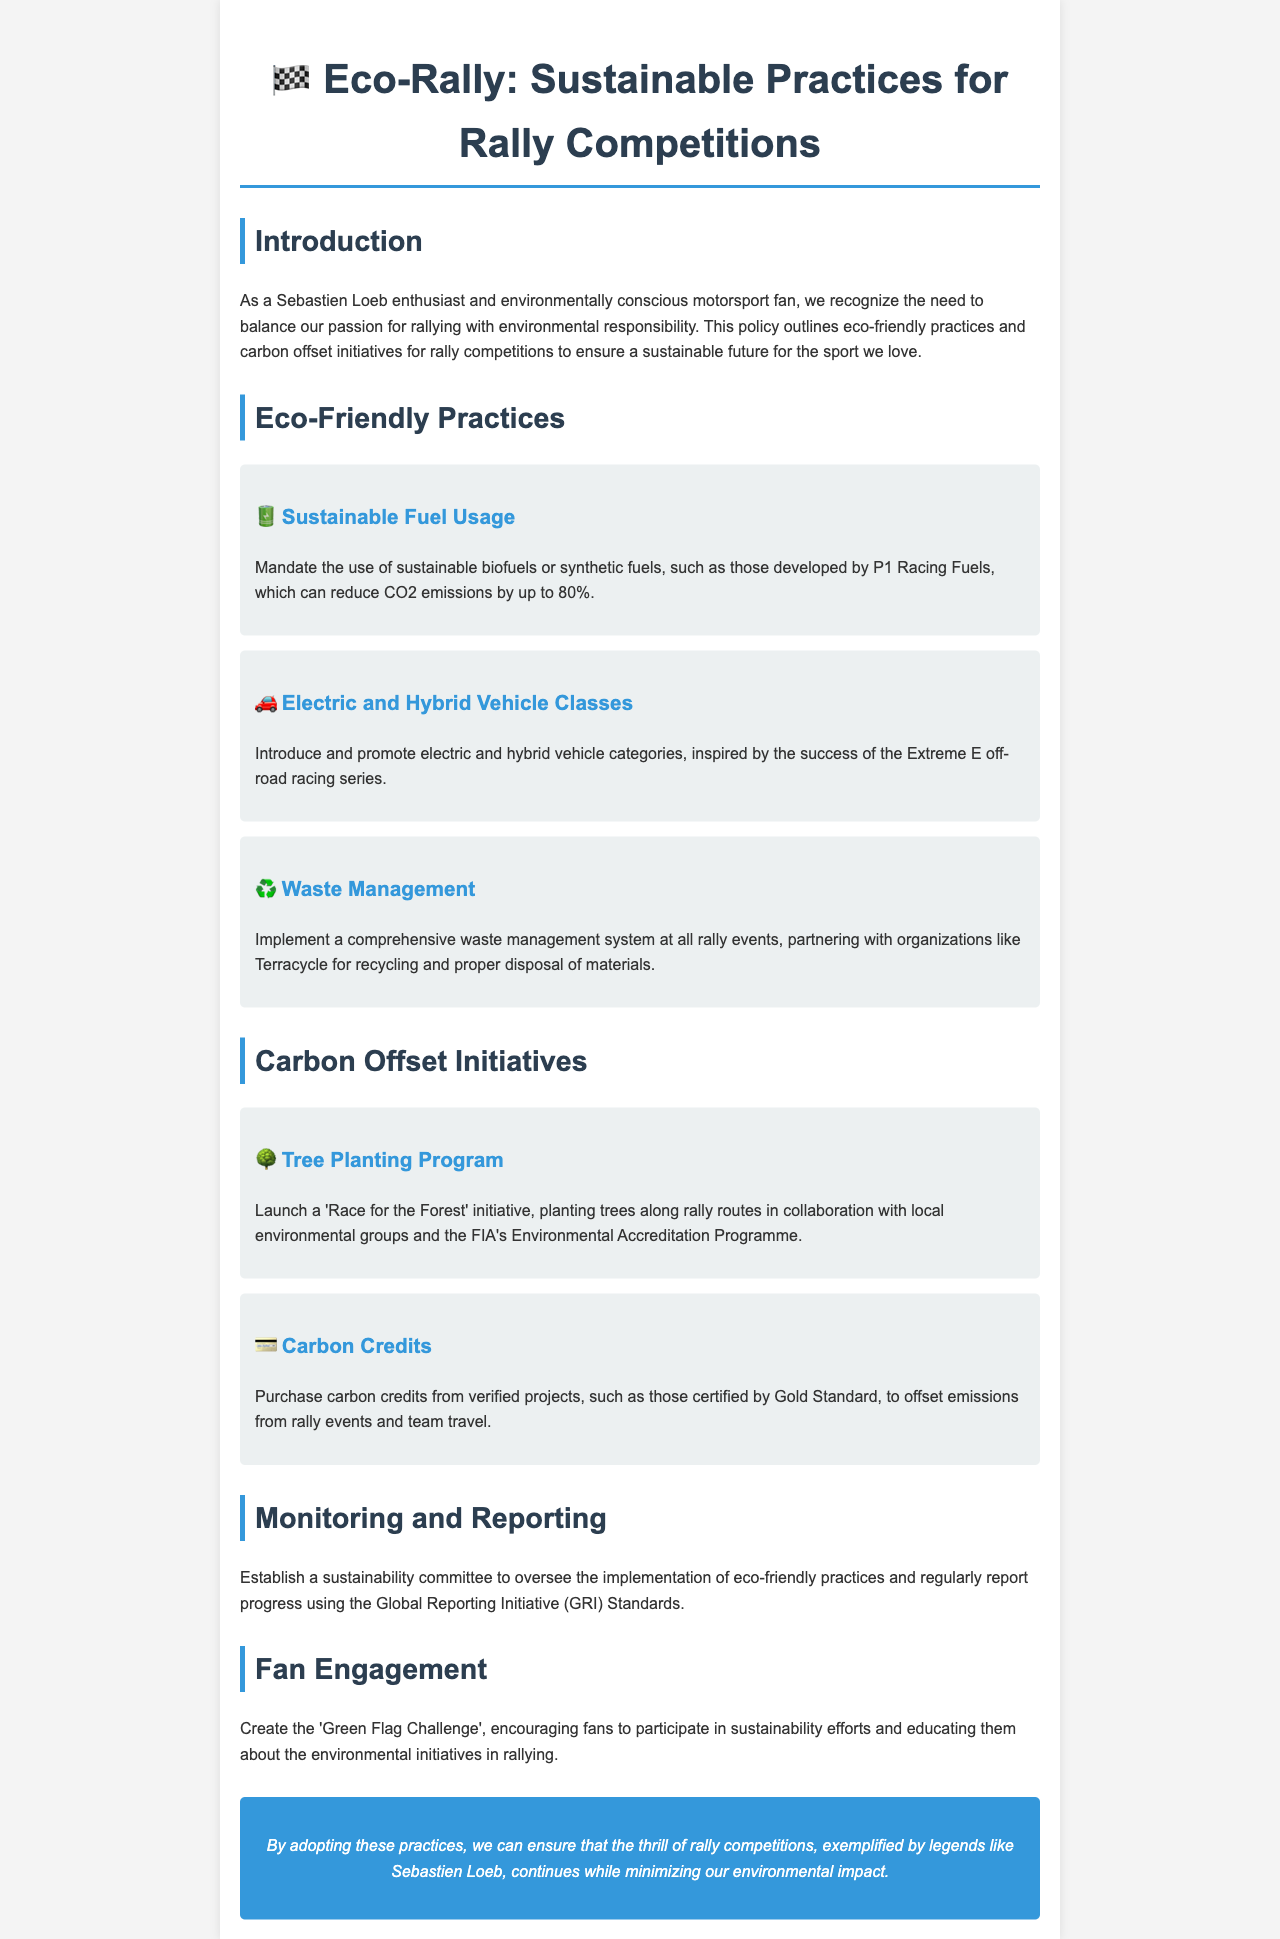what is the title of the document? The title of the document is prominently displayed at the top and provides a clear indication of its focus.
Answer: Eco-Rally: Sustainable Practices for Rally Competitions who is the intended audience for this policy? The introduction specifies the audience that the document aims to address, recognizing their passion for rallying and environmental responsibility.
Answer: Sebastien Loeb enthusiasts and environmentally conscious motorsport fans what initiative involves planting trees? The document mentions a specific initiative aimed at environmental contribution through tree planting.
Answer: Race for the Forest what is the main goal of the sustainability committee? The document states the purpose of forming this committee and the standard it will use to provide oversight.
Answer: Oversee the implementation of eco-friendly practices which organization is mentioned for recycling efforts? The document highlights a specific organization that will partner for establishing a waste management system.
Answer: Terracycle how much can CO2 emissions be reduced by using sustainable fuels? The document provides a measurable figure indicating the potential reduction in emissions through specific fuel use.
Answer: 80% what is the purpose of the Green Flag Challenge? The document describes an initiative aimed at engaging fans and educating them on sustainability in rallying.
Answer: Encourage fans to participate in sustainability efforts what reporting standards will be used for progress tracking? The document specifies the standards to be followed by the sustainability committee to report progress on eco-friendly practices.
Answer: Global Reporting Initiative (GRI) Standards what vehicle categories are promoted in the document? The document introduces specific classes of vehicles aimed at enhancing sustainability in competitions.
Answer: Electric and hybrid vehicle categories 